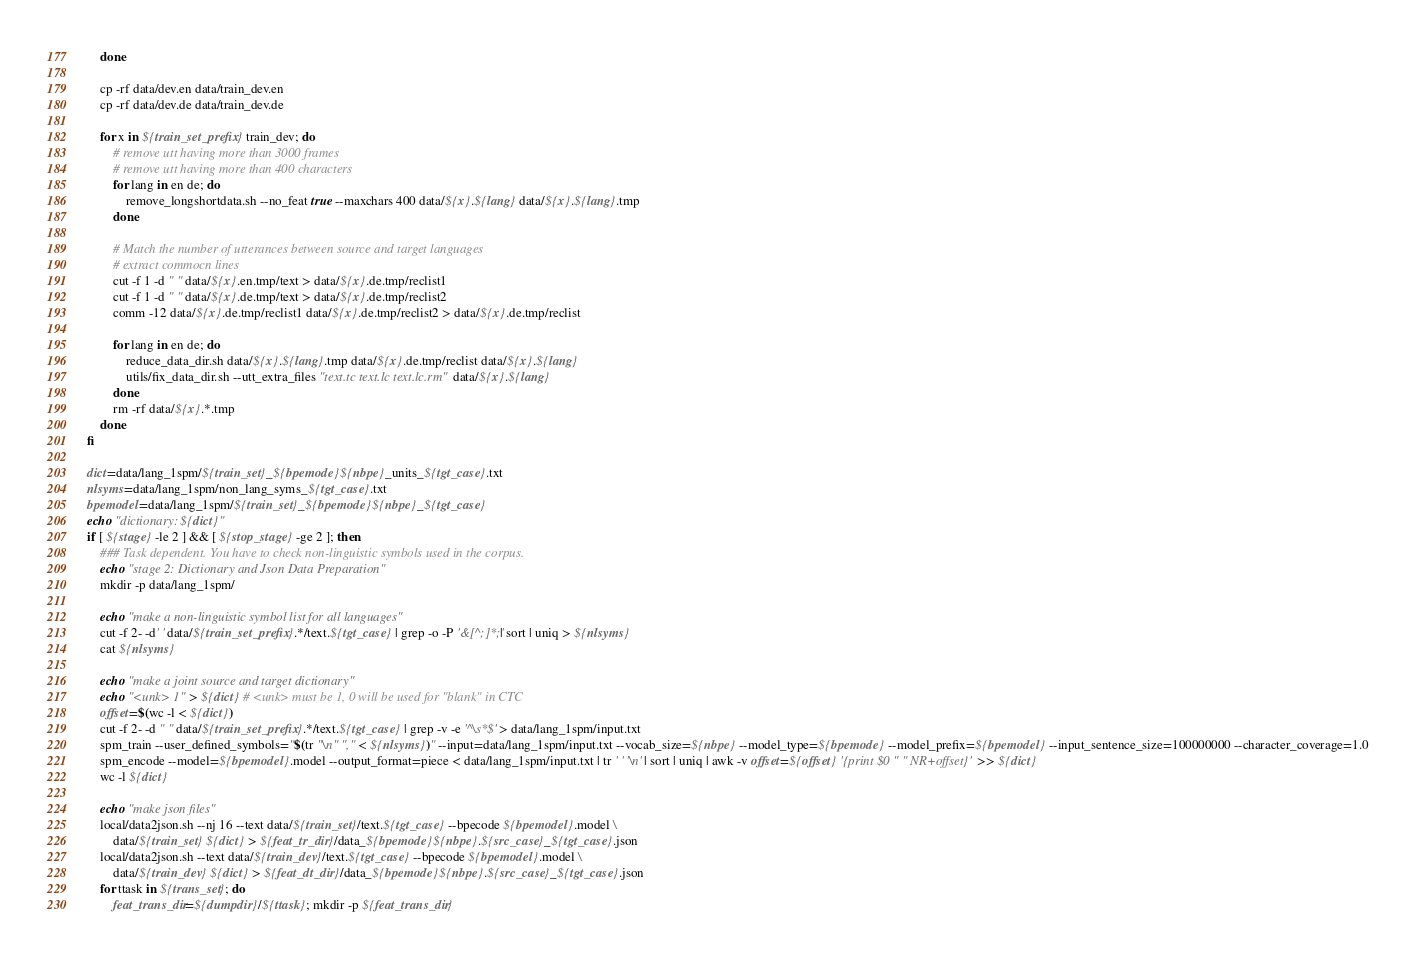<code> <loc_0><loc_0><loc_500><loc_500><_Bash_>    done

    cp -rf data/dev.en data/train_dev.en
    cp -rf data/dev.de data/train_dev.de

    for x in ${train_set_prefix} train_dev; do
        # remove utt having more than 3000 frames
        # remove utt having more than 400 characters
        for lang in en de; do
            remove_longshortdata.sh --no_feat true --maxchars 400 data/${x}.${lang} data/${x}.${lang}.tmp
        done

        # Match the number of utterances between source and target languages
        # extract commocn lines
        cut -f 1 -d " " data/${x}.en.tmp/text > data/${x}.de.tmp/reclist1
        cut -f 1 -d " " data/${x}.de.tmp/text > data/${x}.de.tmp/reclist2
        comm -12 data/${x}.de.tmp/reclist1 data/${x}.de.tmp/reclist2 > data/${x}.de.tmp/reclist

        for lang in en de; do
            reduce_data_dir.sh data/${x}.${lang}.tmp data/${x}.de.tmp/reclist data/${x}.${lang}
            utils/fix_data_dir.sh --utt_extra_files "text.tc text.lc text.lc.rm" data/${x}.${lang}
        done
        rm -rf data/${x}.*.tmp
    done
fi

dict=data/lang_1spm/${train_set}_${bpemode}${nbpe}_units_${tgt_case}.txt
nlsyms=data/lang_1spm/non_lang_syms_${tgt_case}.txt
bpemodel=data/lang_1spm/${train_set}_${bpemode}${nbpe}_${tgt_case}
echo "dictionary: ${dict}"
if [ ${stage} -le 2 ] && [ ${stop_stage} -ge 2 ]; then
    ### Task dependent. You have to check non-linguistic symbols used in the corpus.
    echo "stage 2: Dictionary and Json Data Preparation"
    mkdir -p data/lang_1spm/

    echo "make a non-linguistic symbol list for all languages"
    cut -f 2- -d' ' data/${train_set_prefix}.*/text.${tgt_case} | grep -o -P '&[^;]*;'| sort | uniq > ${nlsyms}
    cat ${nlsyms}

    echo "make a joint source and target dictionary"
    echo "<unk> 1" > ${dict} # <unk> must be 1, 0 will be used for "blank" in CTC
    offset=$(wc -l < ${dict})
    cut -f 2- -d " " data/${train_set_prefix}.*/text.${tgt_case} | grep -v -e '^\s*$' > data/lang_1spm/input.txt
    spm_train --user_defined_symbols="$(tr "\n" "," < ${nlsyms})" --input=data/lang_1spm/input.txt --vocab_size=${nbpe} --model_type=${bpemode} --model_prefix=${bpemodel} --input_sentence_size=100000000 --character_coverage=1.0
    spm_encode --model=${bpemodel}.model --output_format=piece < data/lang_1spm/input.txt | tr ' ' '\n' | sort | uniq | awk -v offset=${offset} '{print $0 " " NR+offset}' >> ${dict}
    wc -l ${dict}

    echo "make json files"
    local/data2json.sh --nj 16 --text data/${train_set}/text.${tgt_case} --bpecode ${bpemodel}.model \
        data/${train_set} ${dict} > ${feat_tr_dir}/data_${bpemode}${nbpe}.${src_case}_${tgt_case}.json
    local/data2json.sh --text data/${train_dev}/text.${tgt_case} --bpecode ${bpemodel}.model \
        data/${train_dev} ${dict} > ${feat_dt_dir}/data_${bpemode}${nbpe}.${src_case}_${tgt_case}.json
    for ttask in ${trans_set}; do
        feat_trans_dir=${dumpdir}/${ttask}; mkdir -p ${feat_trans_dir}</code> 